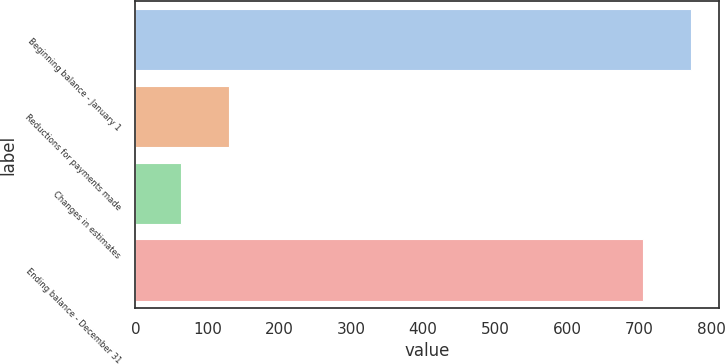Convert chart. <chart><loc_0><loc_0><loc_500><loc_500><bar_chart><fcel>Beginning balance - January 1<fcel>Reductions for payments made<fcel>Changes in estimates<fcel>Ending balance - December 31<nl><fcel>772.7<fcel>130.7<fcel>64<fcel>706<nl></chart> 